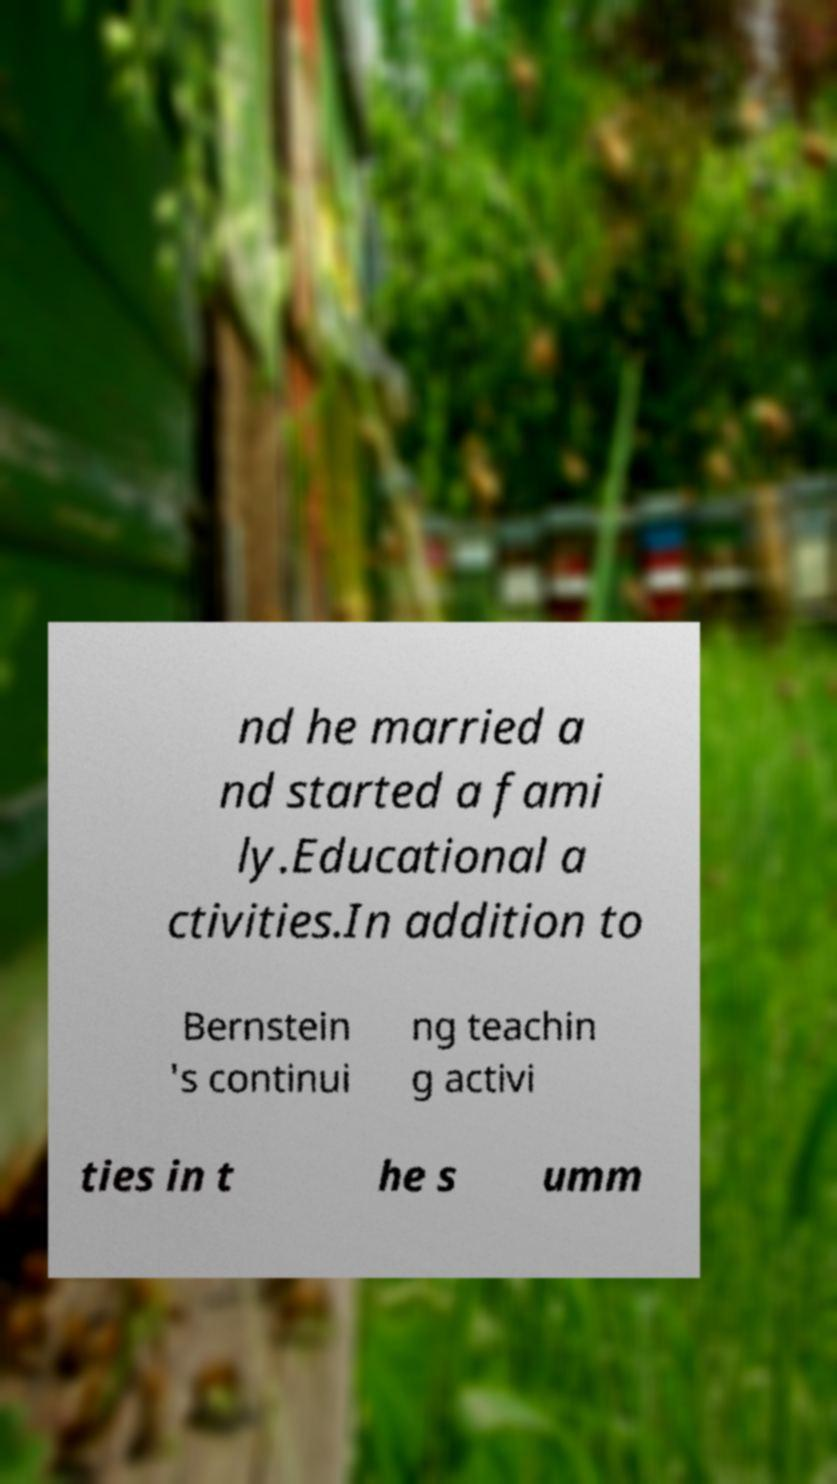Could you extract and type out the text from this image? nd he married a nd started a fami ly.Educational a ctivities.In addition to Bernstein 's continui ng teachin g activi ties in t he s umm 